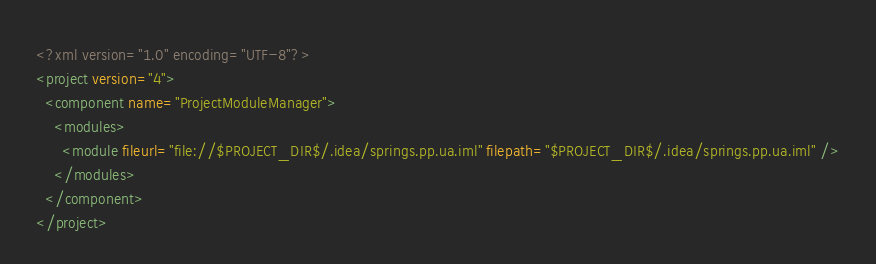<code> <loc_0><loc_0><loc_500><loc_500><_XML_><?xml version="1.0" encoding="UTF-8"?>
<project version="4">
  <component name="ProjectModuleManager">
    <modules>
      <module fileurl="file://$PROJECT_DIR$/.idea/springs.pp.ua.iml" filepath="$PROJECT_DIR$/.idea/springs.pp.ua.iml" />
    </modules>
  </component>
</project></code> 